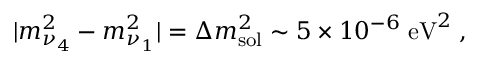<formula> <loc_0><loc_0><loc_500><loc_500>| m _ { \nu _ { 4 } } ^ { 2 } - m _ { \nu _ { 1 } } ^ { 2 } | = \Delta m _ { s o l } ^ { 2 } \sim 5 \times 1 0 ^ { - 6 } \, e V ^ { 2 } \, ,</formula> 